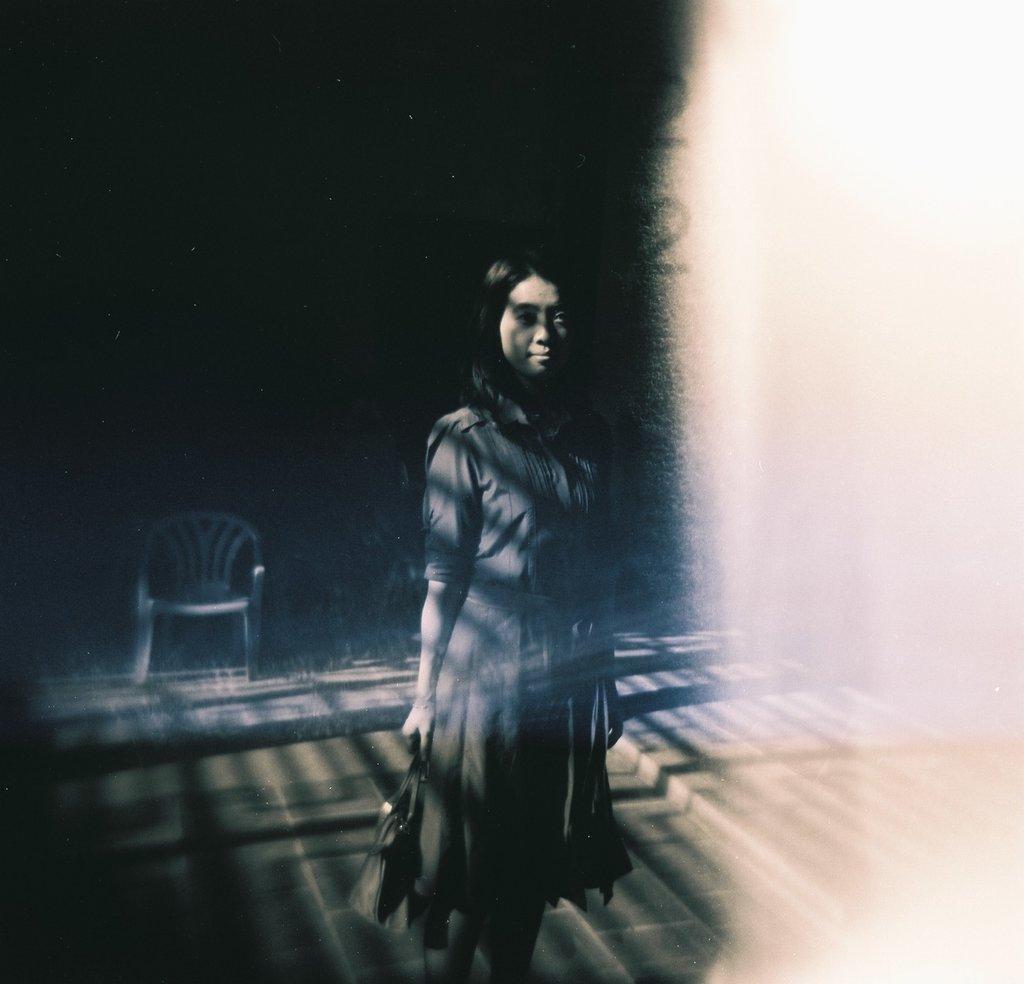What is the lady in the image doing? The lady is standing in the image. What is the lady holding in the image? The lady is holding a bag. Can you describe the background of the image? There is a chair in the background of the image. Is the lady sitting on a pile of coal in the image? There is no coal present in the image, and the lady is standing, not sitting. 